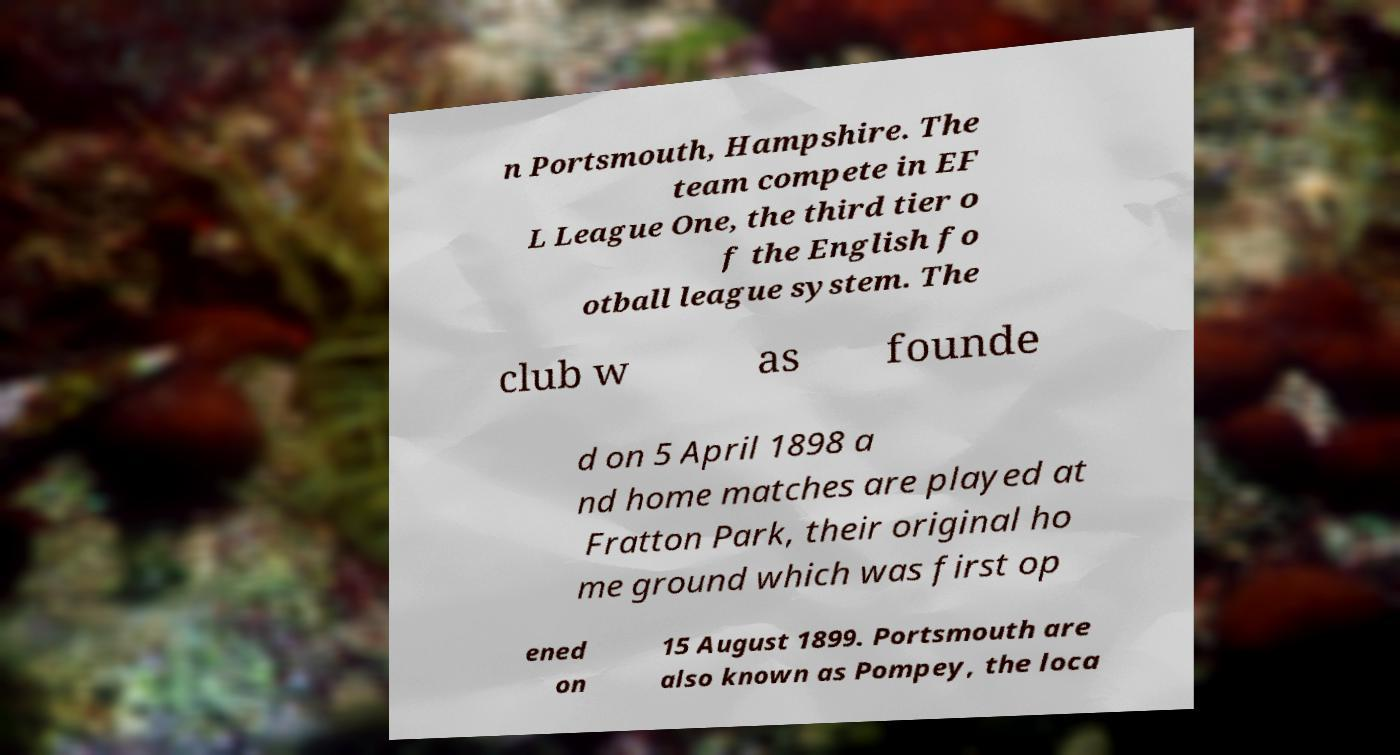There's text embedded in this image that I need extracted. Can you transcribe it verbatim? n Portsmouth, Hampshire. The team compete in EF L League One, the third tier o f the English fo otball league system. The club w as founde d on 5 April 1898 a nd home matches are played at Fratton Park, their original ho me ground which was first op ened on 15 August 1899. Portsmouth are also known as Pompey, the loca 